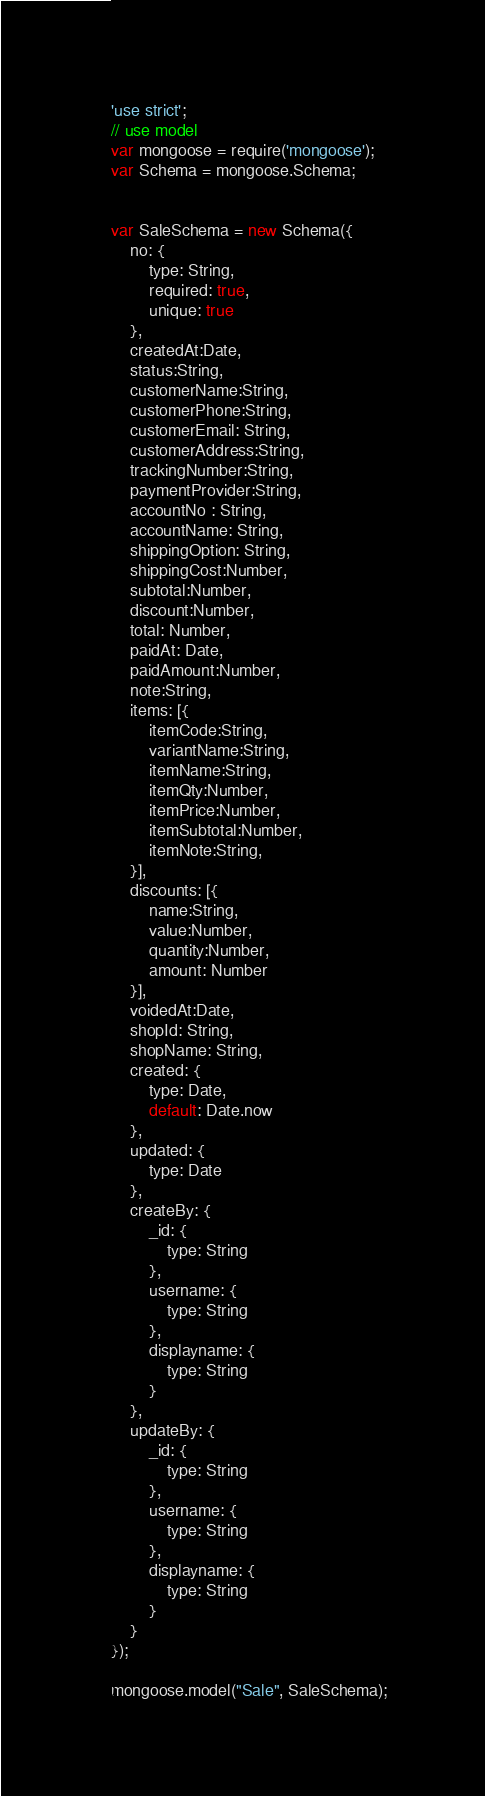Convert code to text. <code><loc_0><loc_0><loc_500><loc_500><_JavaScript_>'use strict';
// use model
var mongoose = require('mongoose');
var Schema = mongoose.Schema;


var SaleSchema = new Schema({
    no: {
        type: String,
        required: true,
        unique: true
    },
    createdAt:Date,	
    status:String,	
    customerName:String,	
    customerPhone:String,	
    customerEmail: String,	
    customerAddress:String,	
    trackingNumber:String,
    paymentProvider:String,	
    accountNo : String,
    accountName: String,	
    shippingOption: String,	
    shippingCost:Number,	
    subtotal:Number,	
    discount:Number,	
    total: Number,	
    paidAt: Date,	
    paidAmount:Number,	
    note:String,	
    items: [{
        itemCode:String,	
        variantName:String,	
        itemName:String,	
        itemQty:Number,	
        itemPrice:Number,	
        itemSubtotal:Number,	
        itemNote:String,
    }],
    discounts: [{
        name:String,
        value:Number,
        quantity:Number,
        amount: Number
    }],
    voidedAt:Date,
    shopId: String,
    shopName: String,
    created: {
        type: Date,
        default: Date.now
    },
    updated: {
        type: Date
    },
    createBy: {
        _id: {
            type: String
        },
        username: {
            type: String
        },
        displayname: {
            type: String
        }
    },
    updateBy: {
        _id: {
            type: String
        },
        username: {
            type: String
        },
        displayname: {
            type: String
        }
    }
});

mongoose.model("Sale", SaleSchema);</code> 